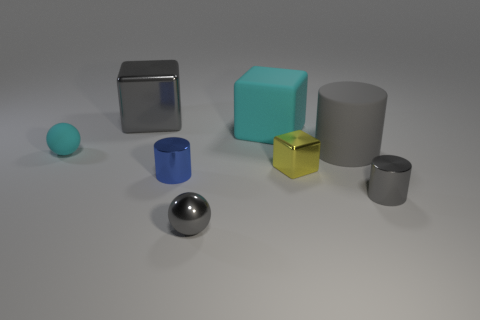Subtract all large gray blocks. How many blocks are left? 2 Add 1 big cyan matte cubes. How many objects exist? 9 Subtract all blocks. How many objects are left? 5 Subtract 2 cylinders. How many cylinders are left? 1 Subtract all large yellow shiny spheres. Subtract all large gray rubber cylinders. How many objects are left? 7 Add 6 big metal objects. How many big metal objects are left? 7 Add 5 tiny yellow cubes. How many tiny yellow cubes exist? 6 Subtract all blue cylinders. How many cylinders are left? 2 Subtract 0 red balls. How many objects are left? 8 Subtract all brown blocks. Subtract all cyan cylinders. How many blocks are left? 3 